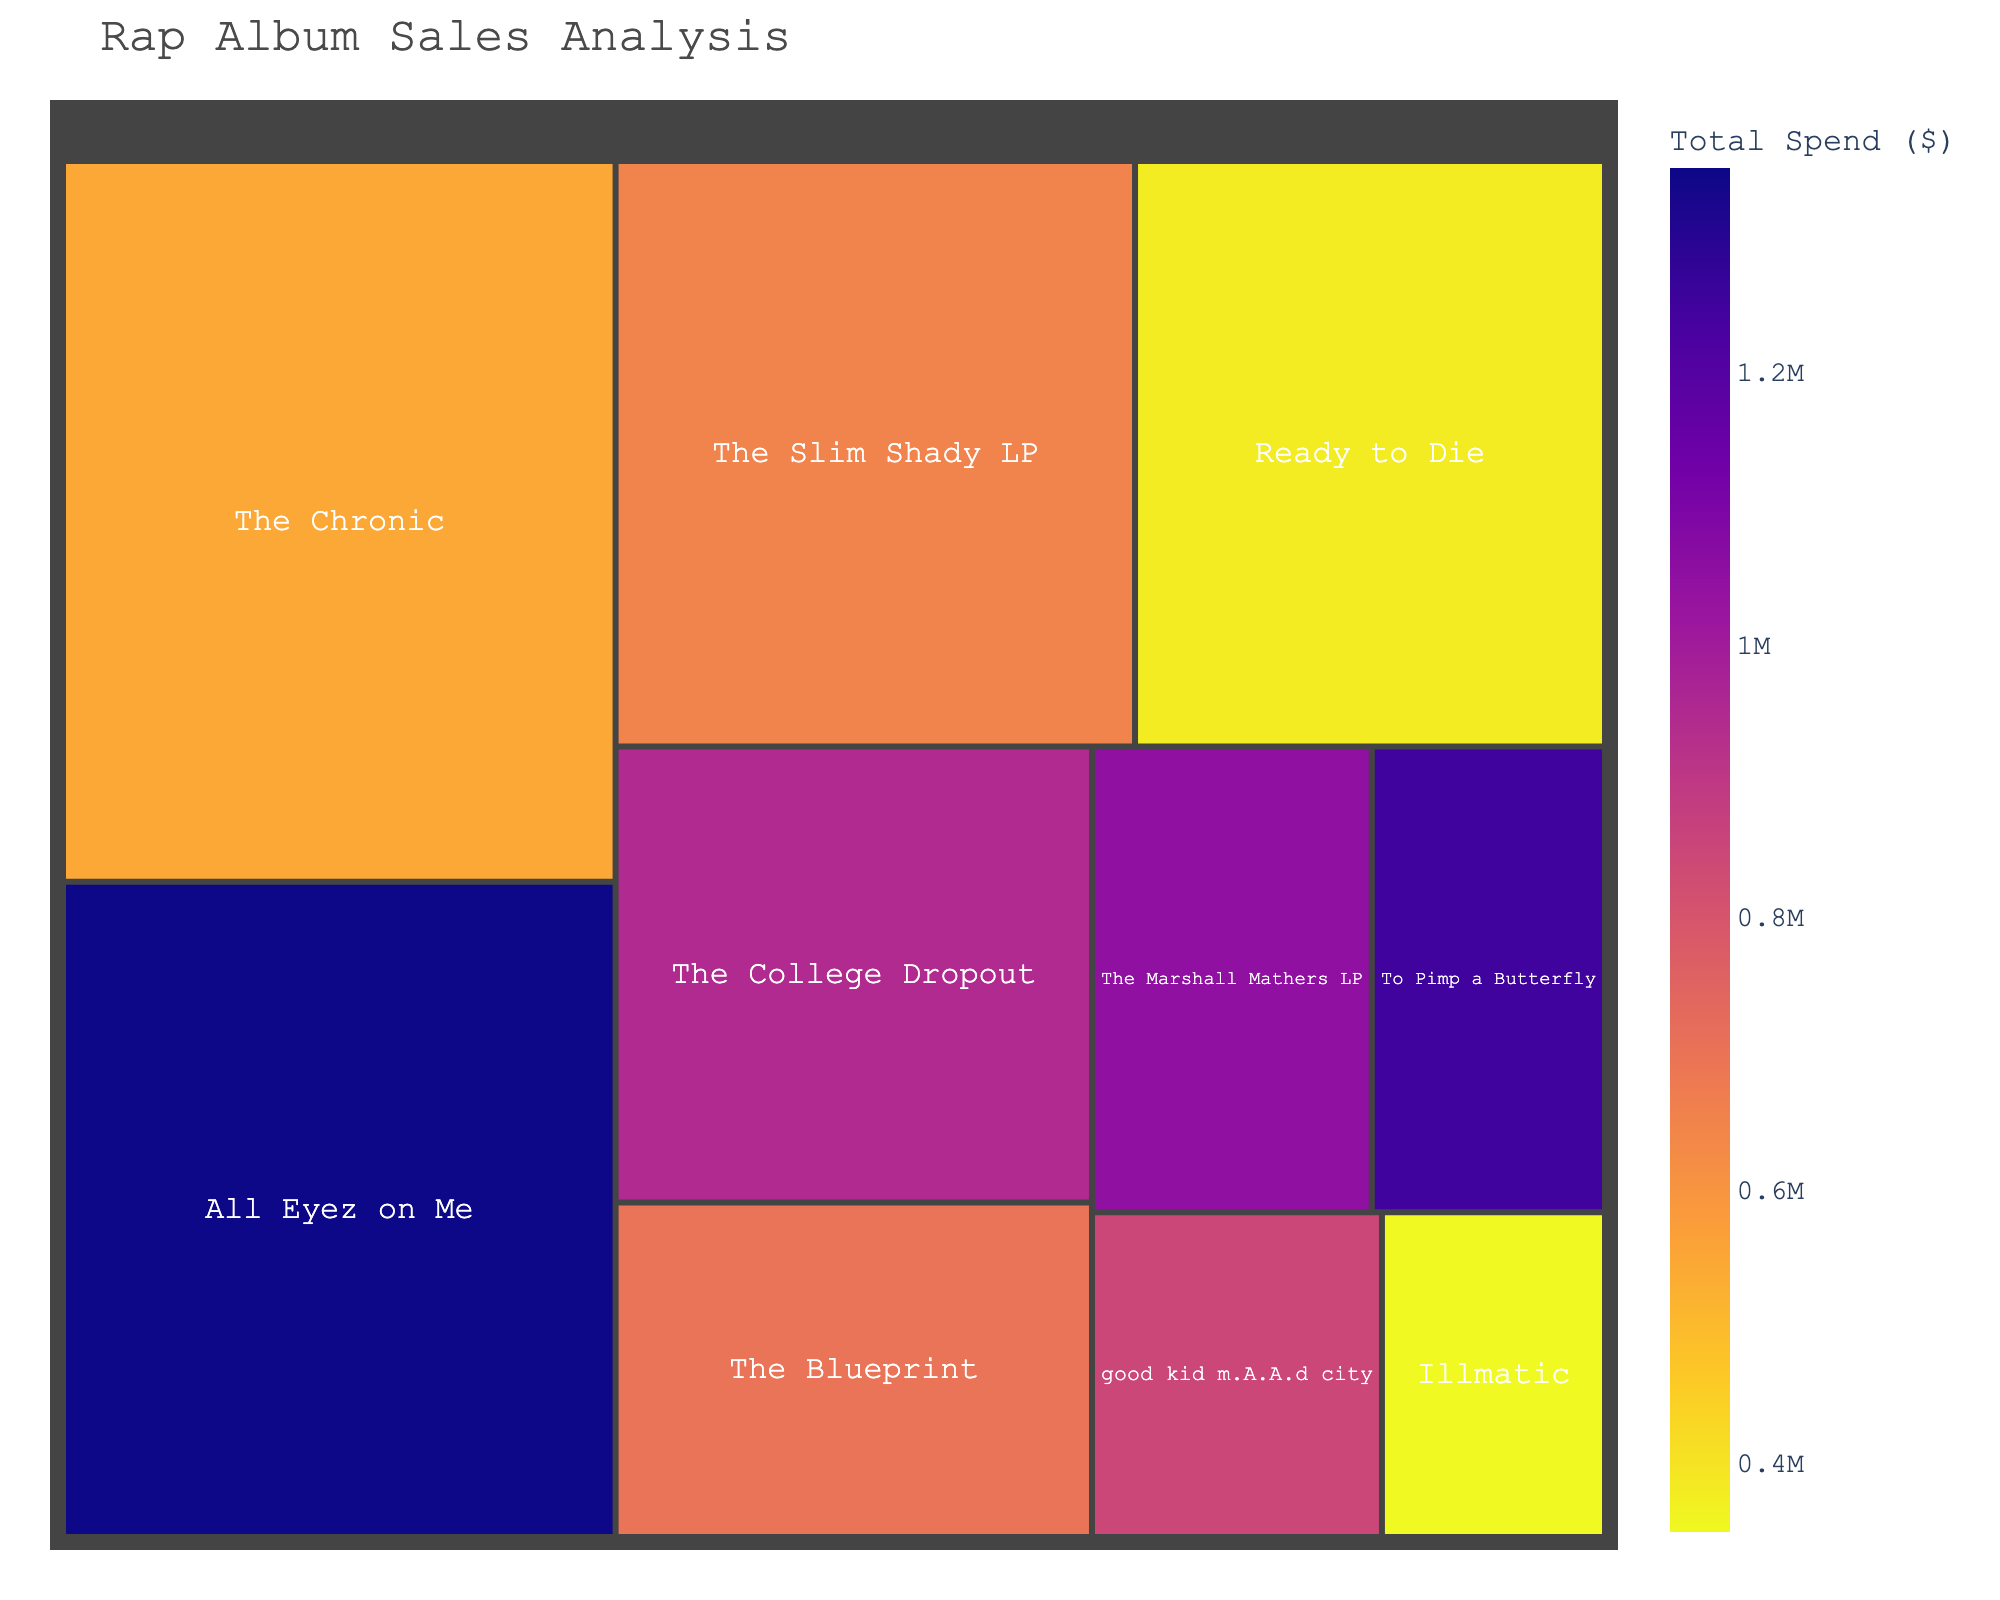What's the title of the Treemap? The title of a figure is usually displayed at the top center of the plot. By locating this text, you can easily identify the title.
Answer: Rap Album Sales Analysis Which album has the highest sales? To identify the album with the highest sales, look for the largest rectangle in the Treemap. The size of the rectangles represents the sales value.
Answer: The Chronic Which album has the lowest production budget? Look at the hover data of each album displayed when you hover over the rectangles in the Treemap. Compare the 'Production Budget' values to find the smallest one.
Answer: Ready to Die What album had the highest total spend? In a treemap, the color intensity reflects a certain value—in this case, the 'Total Spend'. The album with the darkest color represents the highest total spend.
Answer: All Eyez on Me Compare the sales of "The Slim Shady LP" and "Illmatic." Which one is higher? Identify the rectangles corresponding to “The Slim Shady LP” and “Illmatic” in the Treemap. Compare the size of these rectangles, as bigger rectangles represent higher sales.
Answer: The Slim Shady LP What is the total marketing spend for "To Pimp a Butterfly" and "good kid m.A.A.d city"? Hover over both albums "To Pimp a Butterfly" and "good kid m.A.A.d city" to get the marketing spend values and sum them up. $750,000 + $500,000 = $1,250,000
Answer: $1,250,000 Which album has the smallest total spend? The color of the rectangles represents the 'Total Spend' value. The album with the lightest color has the smallest total spend.
Answer: Illmatic How does the marketing spend of "All Eyez on Me" compare to that of "The College Dropout"? Hover over the rectangles for "All Eyez on Me" and "The College Dropout" to display their marketing spends. Compare the values directly. "All Eyez on Me" has $800,000 and "The College Dropout" has $550,000.
Answer: "All Eyez on Me" has a higher marketing spend Which album has sales closest to 2,000,000? Look for the rectangle whose size is close to the size that would represent 2,000,000 in sales. Hovering over each box can confirm the exact sales value.
Answer: The Blueprint What's the average production budget of all albums? Sum up all production budgets and then divide by the number of albums. $\frac{500,000 + 350,000 + 300,000 + 450,000 + 200,000 + 400,000 + 250,000 + 180,000 + 550,000 + 300,000}{10}$ $\approx 348,000$
Answer: $348,000 